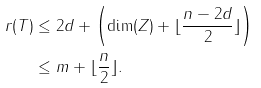Convert formula to latex. <formula><loc_0><loc_0><loc_500><loc_500>r ( T ) & \leq 2 d + \left ( \dim ( Z ) + \lfloor \frac { n - 2 d } { 2 } \rfloor \right ) \\ & \leq m + \lfloor \frac { n } { 2 } \rfloor .</formula> 